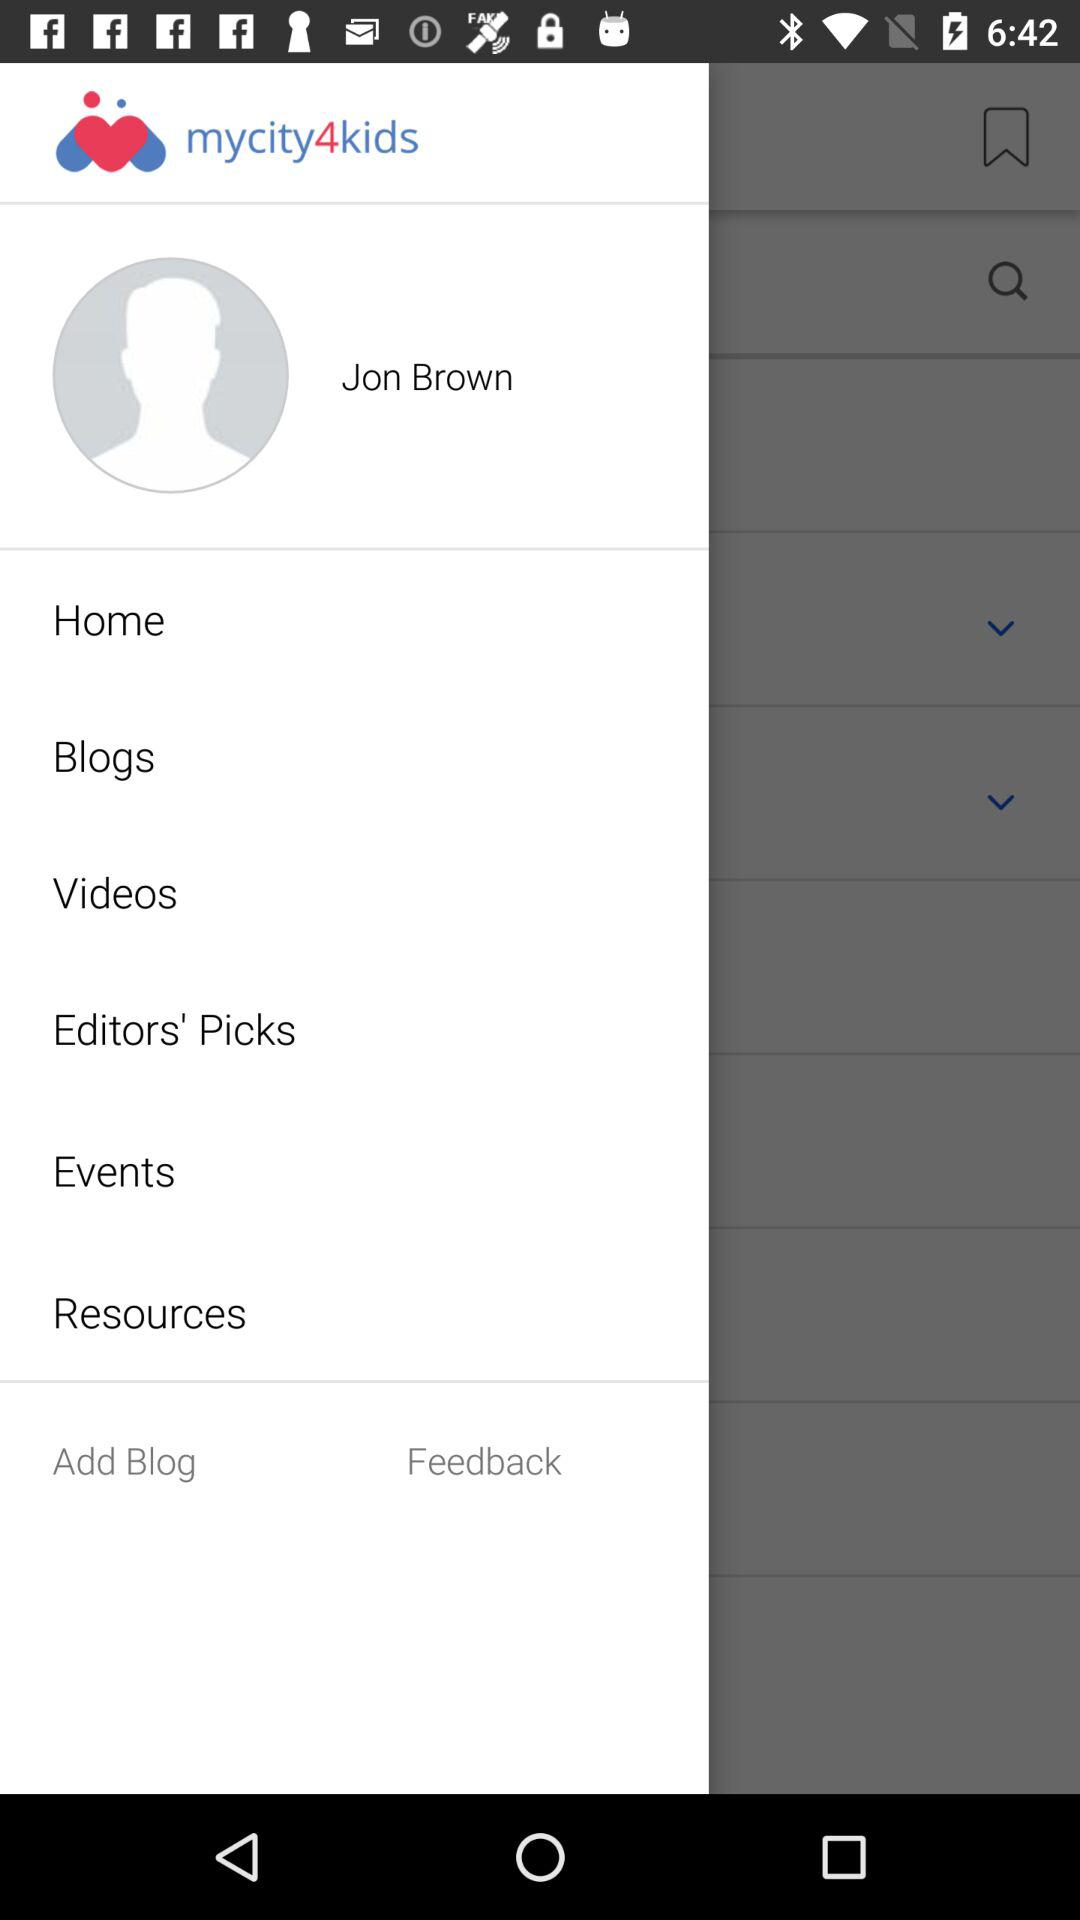What is the user name? The user name is Jon Brown. 